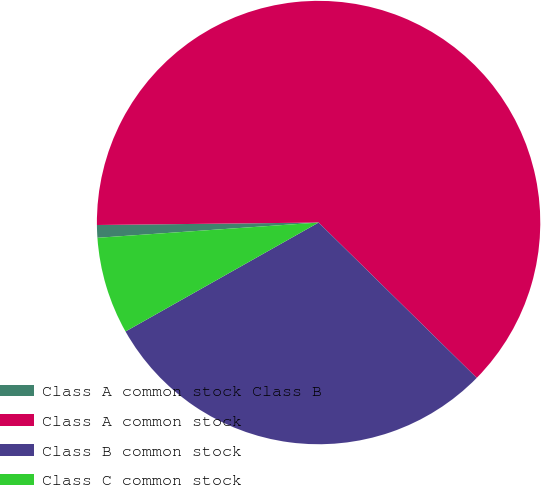<chart> <loc_0><loc_0><loc_500><loc_500><pie_chart><fcel>Class A common stock Class B<fcel>Class A common stock<fcel>Class B common stock<fcel>Class C common stock<nl><fcel>0.92%<fcel>62.54%<fcel>29.47%<fcel>7.08%<nl></chart> 